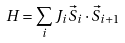<formula> <loc_0><loc_0><loc_500><loc_500>H = \sum _ { i } J _ { i } \vec { S } _ { i } \cdot \vec { S } _ { i + 1 }</formula> 